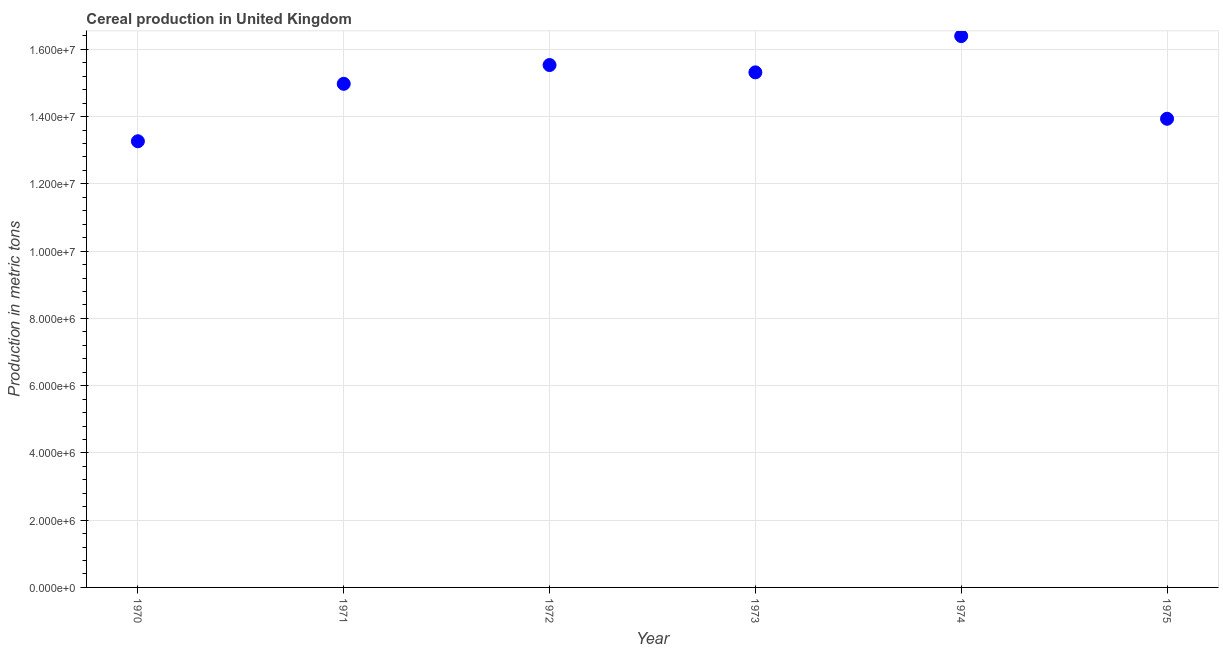What is the cereal production in 1975?
Give a very brief answer. 1.39e+07. Across all years, what is the maximum cereal production?
Your response must be concise. 1.64e+07. Across all years, what is the minimum cereal production?
Your answer should be compact. 1.33e+07. In which year was the cereal production maximum?
Provide a succinct answer. 1974. What is the sum of the cereal production?
Offer a very short reply. 8.94e+07. What is the difference between the cereal production in 1972 and 1973?
Make the answer very short. 2.18e+05. What is the average cereal production per year?
Give a very brief answer. 1.49e+07. What is the median cereal production?
Your response must be concise. 1.51e+07. Do a majority of the years between 1970 and 1973 (inclusive) have cereal production greater than 15200000 metric tons?
Provide a short and direct response. No. What is the ratio of the cereal production in 1970 to that in 1975?
Offer a very short reply. 0.95. What is the difference between the highest and the second highest cereal production?
Keep it short and to the point. 8.61e+05. What is the difference between the highest and the lowest cereal production?
Make the answer very short. 3.13e+06. Does the cereal production monotonically increase over the years?
Make the answer very short. No. What is the difference between two consecutive major ticks on the Y-axis?
Make the answer very short. 2.00e+06. Are the values on the major ticks of Y-axis written in scientific E-notation?
Offer a terse response. Yes. Does the graph contain any zero values?
Offer a terse response. No. What is the title of the graph?
Offer a terse response. Cereal production in United Kingdom. What is the label or title of the X-axis?
Offer a very short reply. Year. What is the label or title of the Y-axis?
Offer a very short reply. Production in metric tons. What is the Production in metric tons in 1970?
Keep it short and to the point. 1.33e+07. What is the Production in metric tons in 1971?
Give a very brief answer. 1.50e+07. What is the Production in metric tons in 1972?
Keep it short and to the point. 1.55e+07. What is the Production in metric tons in 1973?
Ensure brevity in your answer.  1.53e+07. What is the Production in metric tons in 1974?
Provide a succinct answer. 1.64e+07. What is the Production in metric tons in 1975?
Keep it short and to the point. 1.39e+07. What is the difference between the Production in metric tons in 1970 and 1971?
Provide a succinct answer. -1.71e+06. What is the difference between the Production in metric tons in 1970 and 1972?
Your answer should be compact. -2.27e+06. What is the difference between the Production in metric tons in 1970 and 1973?
Provide a succinct answer. -2.05e+06. What is the difference between the Production in metric tons in 1970 and 1974?
Offer a terse response. -3.13e+06. What is the difference between the Production in metric tons in 1970 and 1975?
Offer a very short reply. -6.69e+05. What is the difference between the Production in metric tons in 1971 and 1972?
Provide a succinct answer. -5.59e+05. What is the difference between the Production in metric tons in 1971 and 1973?
Keep it short and to the point. -3.41e+05. What is the difference between the Production in metric tons in 1971 and 1974?
Give a very brief answer. -1.42e+06. What is the difference between the Production in metric tons in 1971 and 1975?
Offer a very short reply. 1.04e+06. What is the difference between the Production in metric tons in 1972 and 1973?
Your response must be concise. 2.18e+05. What is the difference between the Production in metric tons in 1972 and 1974?
Your answer should be very brief. -8.61e+05. What is the difference between the Production in metric tons in 1972 and 1975?
Ensure brevity in your answer.  1.60e+06. What is the difference between the Production in metric tons in 1973 and 1974?
Your answer should be very brief. -1.08e+06. What is the difference between the Production in metric tons in 1973 and 1975?
Your answer should be compact. 1.38e+06. What is the difference between the Production in metric tons in 1974 and 1975?
Keep it short and to the point. 2.46e+06. What is the ratio of the Production in metric tons in 1970 to that in 1971?
Ensure brevity in your answer.  0.89. What is the ratio of the Production in metric tons in 1970 to that in 1972?
Your response must be concise. 0.85. What is the ratio of the Production in metric tons in 1970 to that in 1973?
Your response must be concise. 0.87. What is the ratio of the Production in metric tons in 1970 to that in 1974?
Give a very brief answer. 0.81. What is the ratio of the Production in metric tons in 1971 to that in 1972?
Offer a terse response. 0.96. What is the ratio of the Production in metric tons in 1971 to that in 1973?
Your response must be concise. 0.98. What is the ratio of the Production in metric tons in 1971 to that in 1974?
Give a very brief answer. 0.91. What is the ratio of the Production in metric tons in 1971 to that in 1975?
Keep it short and to the point. 1.07. What is the ratio of the Production in metric tons in 1972 to that in 1974?
Provide a succinct answer. 0.95. What is the ratio of the Production in metric tons in 1972 to that in 1975?
Provide a succinct answer. 1.11. What is the ratio of the Production in metric tons in 1973 to that in 1974?
Provide a succinct answer. 0.93. What is the ratio of the Production in metric tons in 1973 to that in 1975?
Offer a terse response. 1.1. What is the ratio of the Production in metric tons in 1974 to that in 1975?
Your response must be concise. 1.18. 